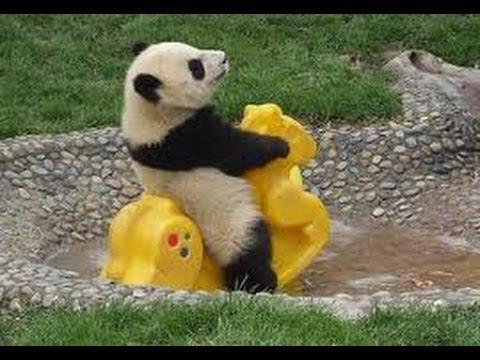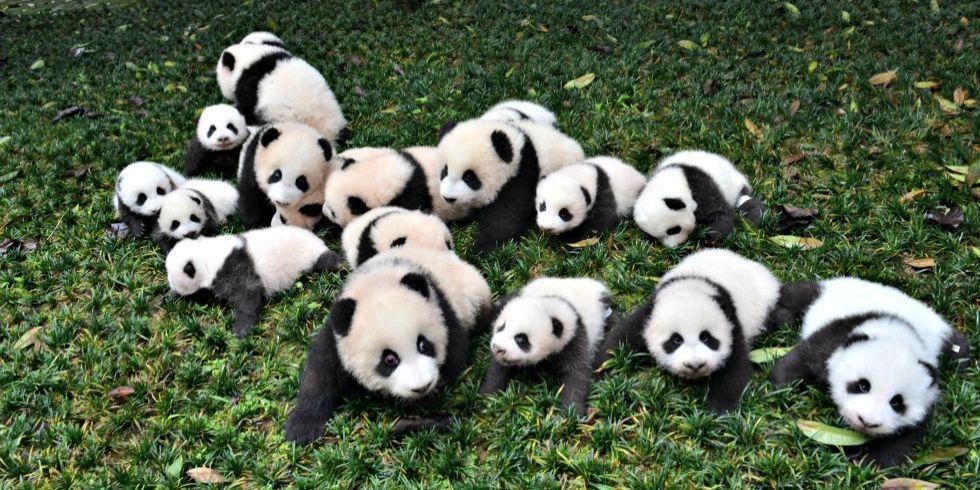The first image is the image on the left, the second image is the image on the right. For the images shown, is this caption "At least one image shows multiple pandas piled on a flat green surface resembling a tablecloth." true? Answer yes or no. No. 